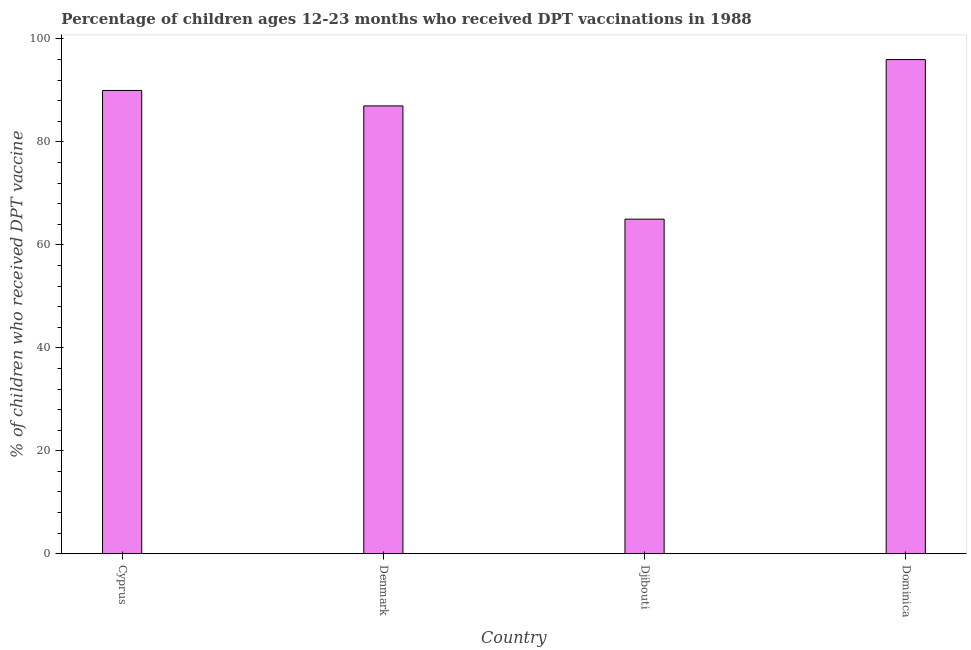Does the graph contain any zero values?
Make the answer very short. No. What is the title of the graph?
Make the answer very short. Percentage of children ages 12-23 months who received DPT vaccinations in 1988. What is the label or title of the Y-axis?
Provide a succinct answer. % of children who received DPT vaccine. What is the percentage of children who received dpt vaccine in Cyprus?
Your answer should be very brief. 90. Across all countries, what is the maximum percentage of children who received dpt vaccine?
Ensure brevity in your answer.  96. In which country was the percentage of children who received dpt vaccine maximum?
Give a very brief answer. Dominica. In which country was the percentage of children who received dpt vaccine minimum?
Ensure brevity in your answer.  Djibouti. What is the sum of the percentage of children who received dpt vaccine?
Your answer should be compact. 338. What is the difference between the percentage of children who received dpt vaccine in Djibouti and Dominica?
Offer a very short reply. -31. What is the average percentage of children who received dpt vaccine per country?
Keep it short and to the point. 84.5. What is the median percentage of children who received dpt vaccine?
Provide a short and direct response. 88.5. In how many countries, is the percentage of children who received dpt vaccine greater than 48 %?
Offer a very short reply. 4. What is the ratio of the percentage of children who received dpt vaccine in Cyprus to that in Dominica?
Your response must be concise. 0.94. Is the percentage of children who received dpt vaccine in Cyprus less than that in Djibouti?
Offer a very short reply. No. Is the difference between the percentage of children who received dpt vaccine in Denmark and Dominica greater than the difference between any two countries?
Offer a very short reply. No. What is the difference between the highest and the second highest percentage of children who received dpt vaccine?
Offer a very short reply. 6. Is the sum of the percentage of children who received dpt vaccine in Djibouti and Dominica greater than the maximum percentage of children who received dpt vaccine across all countries?
Offer a terse response. Yes. What is the difference between the highest and the lowest percentage of children who received dpt vaccine?
Your answer should be compact. 31. In how many countries, is the percentage of children who received dpt vaccine greater than the average percentage of children who received dpt vaccine taken over all countries?
Offer a terse response. 3. How many countries are there in the graph?
Your answer should be very brief. 4. What is the difference between two consecutive major ticks on the Y-axis?
Give a very brief answer. 20. Are the values on the major ticks of Y-axis written in scientific E-notation?
Your answer should be compact. No. What is the % of children who received DPT vaccine of Cyprus?
Your answer should be very brief. 90. What is the % of children who received DPT vaccine of Dominica?
Keep it short and to the point. 96. What is the difference between the % of children who received DPT vaccine in Cyprus and Djibouti?
Offer a terse response. 25. What is the difference between the % of children who received DPT vaccine in Denmark and Djibouti?
Your answer should be very brief. 22. What is the difference between the % of children who received DPT vaccine in Djibouti and Dominica?
Offer a terse response. -31. What is the ratio of the % of children who received DPT vaccine in Cyprus to that in Denmark?
Keep it short and to the point. 1.03. What is the ratio of the % of children who received DPT vaccine in Cyprus to that in Djibouti?
Give a very brief answer. 1.39. What is the ratio of the % of children who received DPT vaccine in Cyprus to that in Dominica?
Your response must be concise. 0.94. What is the ratio of the % of children who received DPT vaccine in Denmark to that in Djibouti?
Your answer should be compact. 1.34. What is the ratio of the % of children who received DPT vaccine in Denmark to that in Dominica?
Your answer should be compact. 0.91. What is the ratio of the % of children who received DPT vaccine in Djibouti to that in Dominica?
Provide a succinct answer. 0.68. 